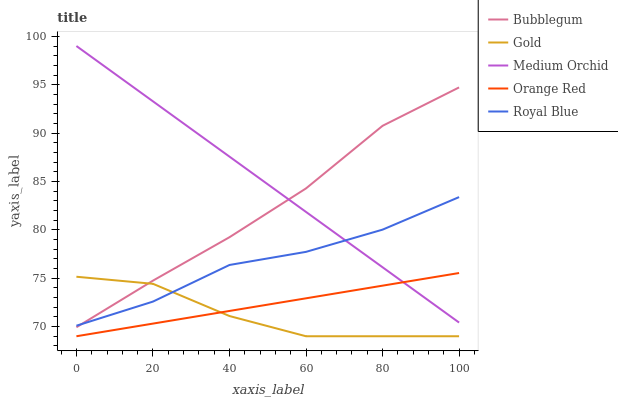Does Gold have the minimum area under the curve?
Answer yes or no. Yes. Does Medium Orchid have the maximum area under the curve?
Answer yes or no. Yes. Does Medium Orchid have the minimum area under the curve?
Answer yes or no. No. Does Gold have the maximum area under the curve?
Answer yes or no. No. Is Medium Orchid the smoothest?
Answer yes or no. Yes. Is Gold the roughest?
Answer yes or no. Yes. Is Gold the smoothest?
Answer yes or no. No. Is Medium Orchid the roughest?
Answer yes or no. No. Does Gold have the lowest value?
Answer yes or no. Yes. Does Medium Orchid have the lowest value?
Answer yes or no. No. Does Medium Orchid have the highest value?
Answer yes or no. Yes. Does Gold have the highest value?
Answer yes or no. No. Is Orange Red less than Royal Blue?
Answer yes or no. Yes. Is Bubblegum greater than Orange Red?
Answer yes or no. Yes. Does Bubblegum intersect Gold?
Answer yes or no. Yes. Is Bubblegum less than Gold?
Answer yes or no. No. Is Bubblegum greater than Gold?
Answer yes or no. No. Does Orange Red intersect Royal Blue?
Answer yes or no. No. 